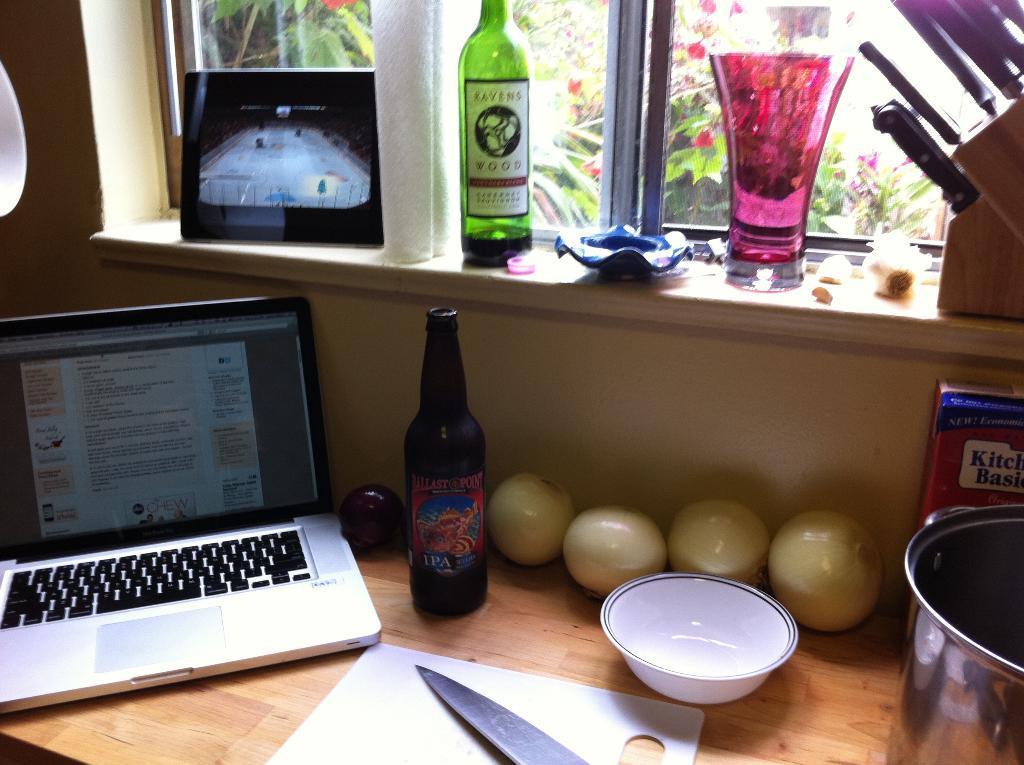Can you describe this image briefly? There is a table in the middle on that table there is a bowl ,bottle ,laptop ,knife and some other items. In background there is a window ,curtain. In the middle there is a glass, bottle and some other items. I think this is a house. 